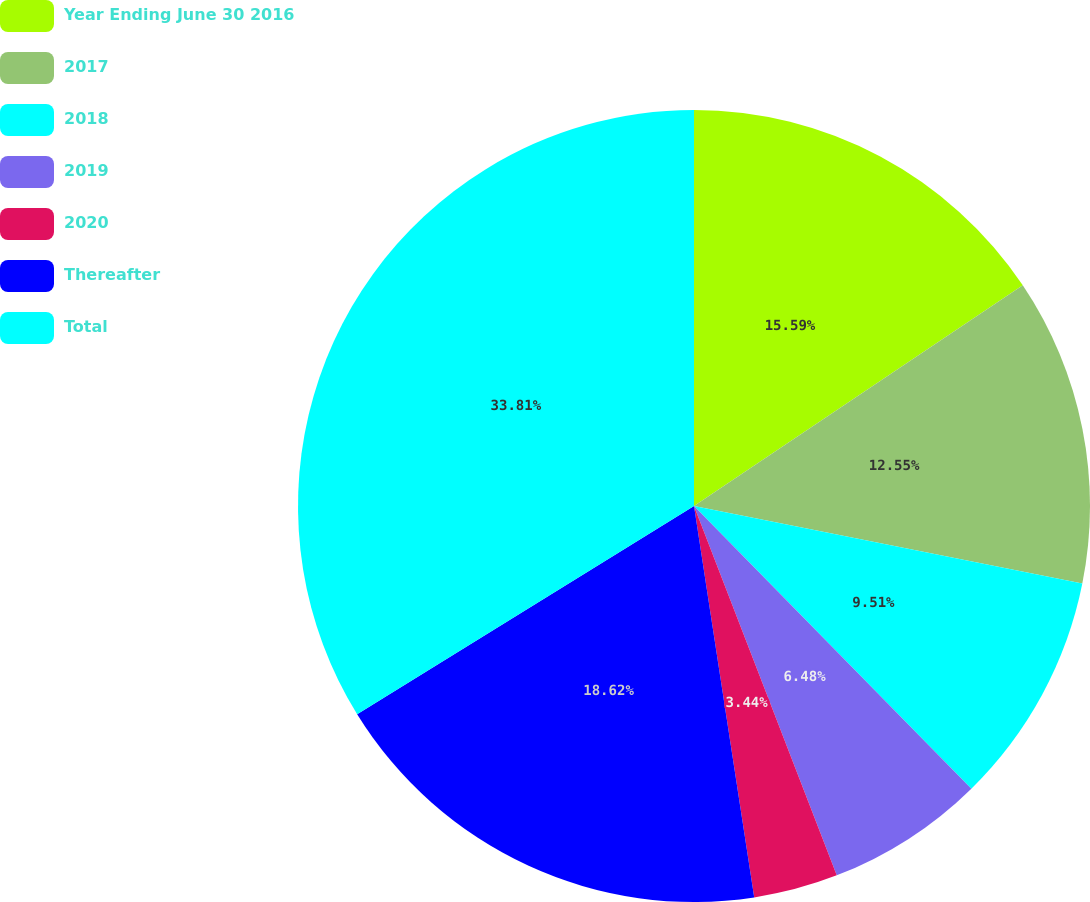Convert chart. <chart><loc_0><loc_0><loc_500><loc_500><pie_chart><fcel>Year Ending June 30 2016<fcel>2017<fcel>2018<fcel>2019<fcel>2020<fcel>Thereafter<fcel>Total<nl><fcel>15.59%<fcel>12.55%<fcel>9.51%<fcel>6.48%<fcel>3.44%<fcel>18.62%<fcel>33.81%<nl></chart> 